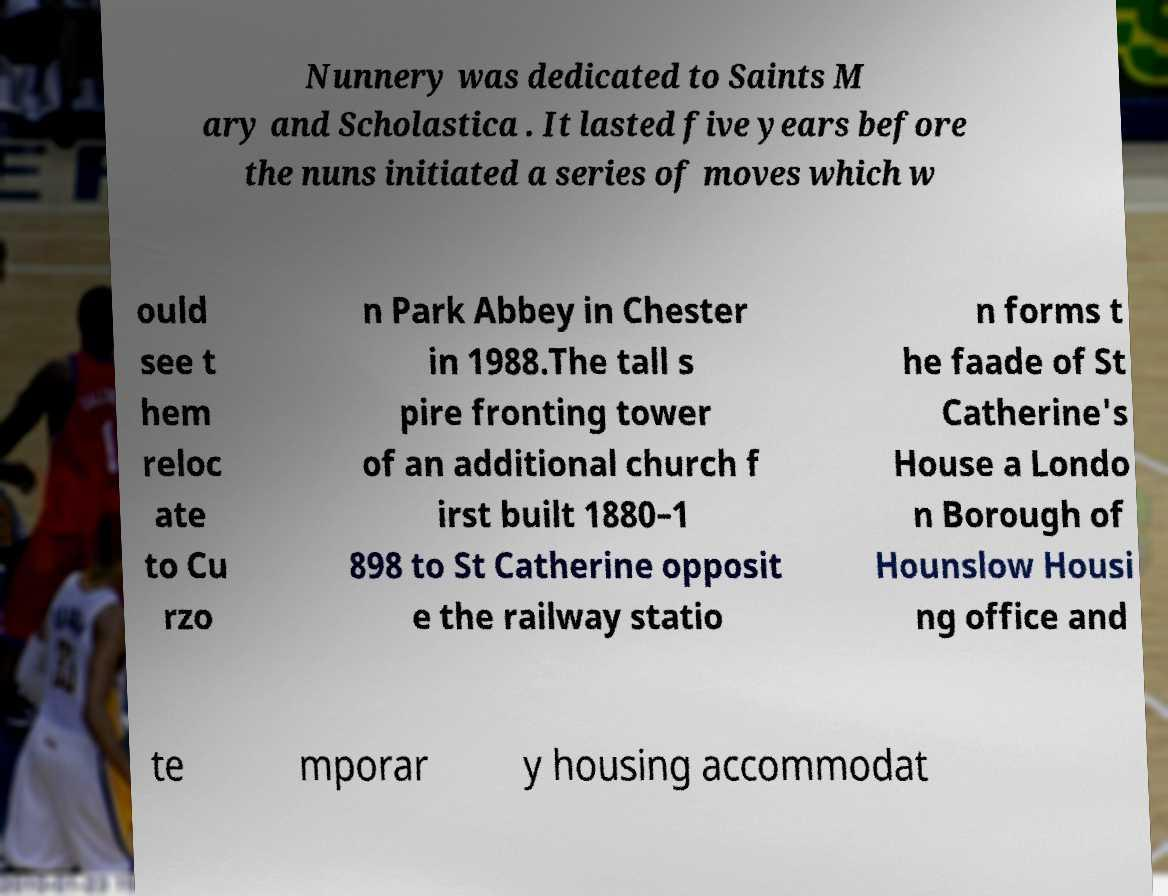What messages or text are displayed in this image? I need them in a readable, typed format. Nunnery was dedicated to Saints M ary and Scholastica . It lasted five years before the nuns initiated a series of moves which w ould see t hem reloc ate to Cu rzo n Park Abbey in Chester in 1988.The tall s pire fronting tower of an additional church f irst built 1880–1 898 to St Catherine opposit e the railway statio n forms t he faade of St Catherine's House a Londo n Borough of Hounslow Housi ng office and te mporar y housing accommodat 